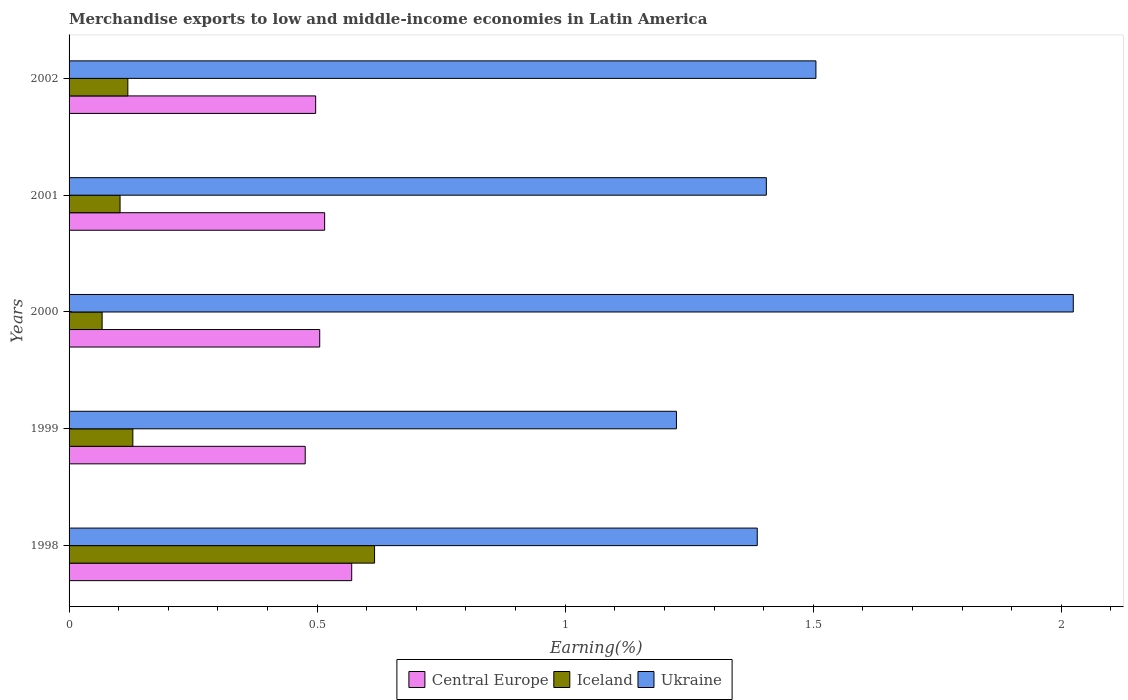How many different coloured bars are there?
Offer a very short reply. 3. How many groups of bars are there?
Make the answer very short. 5. Are the number of bars per tick equal to the number of legend labels?
Your answer should be compact. Yes. How many bars are there on the 5th tick from the top?
Offer a terse response. 3. How many bars are there on the 3rd tick from the bottom?
Offer a terse response. 3. What is the label of the 4th group of bars from the top?
Ensure brevity in your answer.  1999. In how many cases, is the number of bars for a given year not equal to the number of legend labels?
Provide a short and direct response. 0. What is the percentage of amount earned from merchandise exports in Central Europe in 2002?
Provide a short and direct response. 0.5. Across all years, what is the maximum percentage of amount earned from merchandise exports in Iceland?
Keep it short and to the point. 0.62. Across all years, what is the minimum percentage of amount earned from merchandise exports in Ukraine?
Give a very brief answer. 1.22. What is the total percentage of amount earned from merchandise exports in Central Europe in the graph?
Keep it short and to the point. 2.56. What is the difference between the percentage of amount earned from merchandise exports in Central Europe in 1998 and that in 1999?
Your answer should be very brief. 0.09. What is the difference between the percentage of amount earned from merchandise exports in Iceland in 2000 and the percentage of amount earned from merchandise exports in Ukraine in 1998?
Your answer should be compact. -1.32. What is the average percentage of amount earned from merchandise exports in Ukraine per year?
Give a very brief answer. 1.51. In the year 1998, what is the difference between the percentage of amount earned from merchandise exports in Iceland and percentage of amount earned from merchandise exports in Central Europe?
Ensure brevity in your answer.  0.05. What is the ratio of the percentage of amount earned from merchandise exports in Ukraine in 1999 to that in 2000?
Offer a terse response. 0.6. Is the percentage of amount earned from merchandise exports in Ukraine in 1998 less than that in 2002?
Your response must be concise. Yes. Is the difference between the percentage of amount earned from merchandise exports in Iceland in 1999 and 2000 greater than the difference between the percentage of amount earned from merchandise exports in Central Europe in 1999 and 2000?
Make the answer very short. Yes. What is the difference between the highest and the second highest percentage of amount earned from merchandise exports in Iceland?
Give a very brief answer. 0.49. What is the difference between the highest and the lowest percentage of amount earned from merchandise exports in Iceland?
Provide a succinct answer. 0.55. Is the sum of the percentage of amount earned from merchandise exports in Iceland in 2000 and 2002 greater than the maximum percentage of amount earned from merchandise exports in Ukraine across all years?
Offer a terse response. No. What does the 3rd bar from the top in 2000 represents?
Make the answer very short. Central Europe. What does the 3rd bar from the bottom in 2000 represents?
Make the answer very short. Ukraine. Are all the bars in the graph horizontal?
Give a very brief answer. Yes. How many years are there in the graph?
Your answer should be compact. 5. Does the graph contain grids?
Provide a succinct answer. No. Where does the legend appear in the graph?
Provide a succinct answer. Bottom center. How are the legend labels stacked?
Ensure brevity in your answer.  Horizontal. What is the title of the graph?
Provide a short and direct response. Merchandise exports to low and middle-income economies in Latin America. What is the label or title of the X-axis?
Provide a short and direct response. Earning(%). What is the Earning(%) of Central Europe in 1998?
Offer a terse response. 0.57. What is the Earning(%) of Iceland in 1998?
Provide a short and direct response. 0.62. What is the Earning(%) of Ukraine in 1998?
Make the answer very short. 1.39. What is the Earning(%) in Central Europe in 1999?
Provide a succinct answer. 0.48. What is the Earning(%) in Iceland in 1999?
Ensure brevity in your answer.  0.13. What is the Earning(%) of Ukraine in 1999?
Ensure brevity in your answer.  1.22. What is the Earning(%) in Central Europe in 2000?
Offer a terse response. 0.51. What is the Earning(%) of Iceland in 2000?
Provide a short and direct response. 0.07. What is the Earning(%) in Ukraine in 2000?
Your answer should be compact. 2.02. What is the Earning(%) of Central Europe in 2001?
Make the answer very short. 0.52. What is the Earning(%) of Iceland in 2001?
Your answer should be compact. 0.1. What is the Earning(%) in Ukraine in 2001?
Offer a very short reply. 1.41. What is the Earning(%) of Central Europe in 2002?
Make the answer very short. 0.5. What is the Earning(%) of Iceland in 2002?
Make the answer very short. 0.12. What is the Earning(%) in Ukraine in 2002?
Your response must be concise. 1.51. Across all years, what is the maximum Earning(%) in Central Europe?
Ensure brevity in your answer.  0.57. Across all years, what is the maximum Earning(%) in Iceland?
Your response must be concise. 0.62. Across all years, what is the maximum Earning(%) of Ukraine?
Provide a short and direct response. 2.02. Across all years, what is the minimum Earning(%) of Central Europe?
Offer a terse response. 0.48. Across all years, what is the minimum Earning(%) in Iceland?
Provide a short and direct response. 0.07. Across all years, what is the minimum Earning(%) of Ukraine?
Your answer should be very brief. 1.22. What is the total Earning(%) in Central Europe in the graph?
Your response must be concise. 2.56. What is the total Earning(%) in Iceland in the graph?
Keep it short and to the point. 1.03. What is the total Earning(%) of Ukraine in the graph?
Your answer should be very brief. 7.55. What is the difference between the Earning(%) in Central Europe in 1998 and that in 1999?
Offer a terse response. 0.09. What is the difference between the Earning(%) in Iceland in 1998 and that in 1999?
Provide a short and direct response. 0.49. What is the difference between the Earning(%) of Ukraine in 1998 and that in 1999?
Make the answer very short. 0.16. What is the difference between the Earning(%) in Central Europe in 1998 and that in 2000?
Your response must be concise. 0.06. What is the difference between the Earning(%) of Iceland in 1998 and that in 2000?
Ensure brevity in your answer.  0.55. What is the difference between the Earning(%) in Ukraine in 1998 and that in 2000?
Ensure brevity in your answer.  -0.64. What is the difference between the Earning(%) in Central Europe in 1998 and that in 2001?
Ensure brevity in your answer.  0.05. What is the difference between the Earning(%) in Iceland in 1998 and that in 2001?
Your answer should be compact. 0.51. What is the difference between the Earning(%) in Ukraine in 1998 and that in 2001?
Give a very brief answer. -0.02. What is the difference between the Earning(%) of Central Europe in 1998 and that in 2002?
Your response must be concise. 0.07. What is the difference between the Earning(%) of Iceland in 1998 and that in 2002?
Offer a very short reply. 0.5. What is the difference between the Earning(%) of Ukraine in 1998 and that in 2002?
Provide a succinct answer. -0.12. What is the difference between the Earning(%) in Central Europe in 1999 and that in 2000?
Keep it short and to the point. -0.03. What is the difference between the Earning(%) in Iceland in 1999 and that in 2000?
Your response must be concise. 0.06. What is the difference between the Earning(%) in Ukraine in 1999 and that in 2000?
Offer a very short reply. -0.8. What is the difference between the Earning(%) in Central Europe in 1999 and that in 2001?
Your answer should be very brief. -0.04. What is the difference between the Earning(%) in Iceland in 1999 and that in 2001?
Make the answer very short. 0.03. What is the difference between the Earning(%) in Ukraine in 1999 and that in 2001?
Offer a very short reply. -0.18. What is the difference between the Earning(%) of Central Europe in 1999 and that in 2002?
Give a very brief answer. -0.02. What is the difference between the Earning(%) in Iceland in 1999 and that in 2002?
Make the answer very short. 0.01. What is the difference between the Earning(%) in Ukraine in 1999 and that in 2002?
Your response must be concise. -0.28. What is the difference between the Earning(%) in Central Europe in 2000 and that in 2001?
Provide a short and direct response. -0.01. What is the difference between the Earning(%) in Iceland in 2000 and that in 2001?
Give a very brief answer. -0.04. What is the difference between the Earning(%) of Ukraine in 2000 and that in 2001?
Give a very brief answer. 0.62. What is the difference between the Earning(%) in Central Europe in 2000 and that in 2002?
Provide a short and direct response. 0.01. What is the difference between the Earning(%) of Iceland in 2000 and that in 2002?
Offer a very short reply. -0.05. What is the difference between the Earning(%) of Ukraine in 2000 and that in 2002?
Offer a terse response. 0.52. What is the difference between the Earning(%) in Central Europe in 2001 and that in 2002?
Your response must be concise. 0.02. What is the difference between the Earning(%) in Iceland in 2001 and that in 2002?
Give a very brief answer. -0.02. What is the difference between the Earning(%) of Central Europe in 1998 and the Earning(%) of Iceland in 1999?
Provide a succinct answer. 0.44. What is the difference between the Earning(%) of Central Europe in 1998 and the Earning(%) of Ukraine in 1999?
Your answer should be very brief. -0.65. What is the difference between the Earning(%) of Iceland in 1998 and the Earning(%) of Ukraine in 1999?
Your response must be concise. -0.61. What is the difference between the Earning(%) of Central Europe in 1998 and the Earning(%) of Iceland in 2000?
Provide a short and direct response. 0.5. What is the difference between the Earning(%) in Central Europe in 1998 and the Earning(%) in Ukraine in 2000?
Offer a very short reply. -1.45. What is the difference between the Earning(%) of Iceland in 1998 and the Earning(%) of Ukraine in 2000?
Keep it short and to the point. -1.41. What is the difference between the Earning(%) of Central Europe in 1998 and the Earning(%) of Iceland in 2001?
Provide a short and direct response. 0.47. What is the difference between the Earning(%) of Central Europe in 1998 and the Earning(%) of Ukraine in 2001?
Provide a short and direct response. -0.84. What is the difference between the Earning(%) of Iceland in 1998 and the Earning(%) of Ukraine in 2001?
Make the answer very short. -0.79. What is the difference between the Earning(%) in Central Europe in 1998 and the Earning(%) in Iceland in 2002?
Offer a terse response. 0.45. What is the difference between the Earning(%) in Central Europe in 1998 and the Earning(%) in Ukraine in 2002?
Keep it short and to the point. -0.94. What is the difference between the Earning(%) in Iceland in 1998 and the Earning(%) in Ukraine in 2002?
Ensure brevity in your answer.  -0.89. What is the difference between the Earning(%) in Central Europe in 1999 and the Earning(%) in Iceland in 2000?
Provide a short and direct response. 0.41. What is the difference between the Earning(%) in Central Europe in 1999 and the Earning(%) in Ukraine in 2000?
Your response must be concise. -1.55. What is the difference between the Earning(%) in Iceland in 1999 and the Earning(%) in Ukraine in 2000?
Your answer should be compact. -1.9. What is the difference between the Earning(%) in Central Europe in 1999 and the Earning(%) in Iceland in 2001?
Make the answer very short. 0.37. What is the difference between the Earning(%) of Central Europe in 1999 and the Earning(%) of Ukraine in 2001?
Offer a very short reply. -0.93. What is the difference between the Earning(%) of Iceland in 1999 and the Earning(%) of Ukraine in 2001?
Give a very brief answer. -1.28. What is the difference between the Earning(%) of Central Europe in 1999 and the Earning(%) of Iceland in 2002?
Offer a very short reply. 0.36. What is the difference between the Earning(%) of Central Europe in 1999 and the Earning(%) of Ukraine in 2002?
Your answer should be compact. -1.03. What is the difference between the Earning(%) in Iceland in 1999 and the Earning(%) in Ukraine in 2002?
Provide a short and direct response. -1.38. What is the difference between the Earning(%) of Central Europe in 2000 and the Earning(%) of Iceland in 2001?
Keep it short and to the point. 0.4. What is the difference between the Earning(%) in Central Europe in 2000 and the Earning(%) in Ukraine in 2001?
Provide a succinct answer. -0.9. What is the difference between the Earning(%) in Iceland in 2000 and the Earning(%) in Ukraine in 2001?
Offer a very short reply. -1.34. What is the difference between the Earning(%) in Central Europe in 2000 and the Earning(%) in Iceland in 2002?
Provide a succinct answer. 0.39. What is the difference between the Earning(%) in Central Europe in 2000 and the Earning(%) in Ukraine in 2002?
Give a very brief answer. -1. What is the difference between the Earning(%) of Iceland in 2000 and the Earning(%) of Ukraine in 2002?
Your answer should be very brief. -1.44. What is the difference between the Earning(%) in Central Europe in 2001 and the Earning(%) in Iceland in 2002?
Offer a very short reply. 0.4. What is the difference between the Earning(%) in Central Europe in 2001 and the Earning(%) in Ukraine in 2002?
Give a very brief answer. -0.99. What is the difference between the Earning(%) of Iceland in 2001 and the Earning(%) of Ukraine in 2002?
Give a very brief answer. -1.4. What is the average Earning(%) in Central Europe per year?
Give a very brief answer. 0.51. What is the average Earning(%) of Iceland per year?
Offer a very short reply. 0.21. What is the average Earning(%) in Ukraine per year?
Provide a short and direct response. 1.51. In the year 1998, what is the difference between the Earning(%) in Central Europe and Earning(%) in Iceland?
Your response must be concise. -0.05. In the year 1998, what is the difference between the Earning(%) of Central Europe and Earning(%) of Ukraine?
Your response must be concise. -0.82. In the year 1998, what is the difference between the Earning(%) in Iceland and Earning(%) in Ukraine?
Your answer should be very brief. -0.77. In the year 1999, what is the difference between the Earning(%) in Central Europe and Earning(%) in Iceland?
Your answer should be very brief. 0.35. In the year 1999, what is the difference between the Earning(%) in Central Europe and Earning(%) in Ukraine?
Keep it short and to the point. -0.75. In the year 1999, what is the difference between the Earning(%) in Iceland and Earning(%) in Ukraine?
Provide a succinct answer. -1.1. In the year 2000, what is the difference between the Earning(%) of Central Europe and Earning(%) of Iceland?
Provide a short and direct response. 0.44. In the year 2000, what is the difference between the Earning(%) of Central Europe and Earning(%) of Ukraine?
Offer a very short reply. -1.52. In the year 2000, what is the difference between the Earning(%) of Iceland and Earning(%) of Ukraine?
Your answer should be compact. -1.96. In the year 2001, what is the difference between the Earning(%) in Central Europe and Earning(%) in Iceland?
Give a very brief answer. 0.41. In the year 2001, what is the difference between the Earning(%) in Central Europe and Earning(%) in Ukraine?
Your answer should be very brief. -0.89. In the year 2001, what is the difference between the Earning(%) of Iceland and Earning(%) of Ukraine?
Keep it short and to the point. -1.3. In the year 2002, what is the difference between the Earning(%) in Central Europe and Earning(%) in Iceland?
Keep it short and to the point. 0.38. In the year 2002, what is the difference between the Earning(%) of Central Europe and Earning(%) of Ukraine?
Provide a short and direct response. -1.01. In the year 2002, what is the difference between the Earning(%) in Iceland and Earning(%) in Ukraine?
Your answer should be very brief. -1.39. What is the ratio of the Earning(%) in Central Europe in 1998 to that in 1999?
Give a very brief answer. 1.2. What is the ratio of the Earning(%) in Iceland in 1998 to that in 1999?
Give a very brief answer. 4.79. What is the ratio of the Earning(%) of Ukraine in 1998 to that in 1999?
Keep it short and to the point. 1.13. What is the ratio of the Earning(%) in Central Europe in 1998 to that in 2000?
Your answer should be very brief. 1.13. What is the ratio of the Earning(%) in Iceland in 1998 to that in 2000?
Offer a very short reply. 9.24. What is the ratio of the Earning(%) of Ukraine in 1998 to that in 2000?
Make the answer very short. 0.69. What is the ratio of the Earning(%) in Central Europe in 1998 to that in 2001?
Ensure brevity in your answer.  1.11. What is the ratio of the Earning(%) of Iceland in 1998 to that in 2001?
Ensure brevity in your answer.  5.99. What is the ratio of the Earning(%) of Ukraine in 1998 to that in 2001?
Give a very brief answer. 0.99. What is the ratio of the Earning(%) in Central Europe in 1998 to that in 2002?
Your response must be concise. 1.15. What is the ratio of the Earning(%) of Iceland in 1998 to that in 2002?
Your answer should be very brief. 5.2. What is the ratio of the Earning(%) in Ukraine in 1998 to that in 2002?
Keep it short and to the point. 0.92. What is the ratio of the Earning(%) of Central Europe in 1999 to that in 2000?
Give a very brief answer. 0.94. What is the ratio of the Earning(%) of Iceland in 1999 to that in 2000?
Offer a terse response. 1.93. What is the ratio of the Earning(%) of Ukraine in 1999 to that in 2000?
Provide a succinct answer. 0.6. What is the ratio of the Earning(%) of Central Europe in 1999 to that in 2001?
Make the answer very short. 0.92. What is the ratio of the Earning(%) in Iceland in 1999 to that in 2001?
Your answer should be very brief. 1.25. What is the ratio of the Earning(%) of Ukraine in 1999 to that in 2001?
Your response must be concise. 0.87. What is the ratio of the Earning(%) of Central Europe in 1999 to that in 2002?
Your response must be concise. 0.96. What is the ratio of the Earning(%) in Iceland in 1999 to that in 2002?
Make the answer very short. 1.09. What is the ratio of the Earning(%) in Ukraine in 1999 to that in 2002?
Ensure brevity in your answer.  0.81. What is the ratio of the Earning(%) in Central Europe in 2000 to that in 2001?
Keep it short and to the point. 0.98. What is the ratio of the Earning(%) of Iceland in 2000 to that in 2001?
Provide a succinct answer. 0.65. What is the ratio of the Earning(%) in Ukraine in 2000 to that in 2001?
Ensure brevity in your answer.  1.44. What is the ratio of the Earning(%) in Central Europe in 2000 to that in 2002?
Offer a very short reply. 1.02. What is the ratio of the Earning(%) of Iceland in 2000 to that in 2002?
Your response must be concise. 0.56. What is the ratio of the Earning(%) of Ukraine in 2000 to that in 2002?
Offer a very short reply. 1.34. What is the ratio of the Earning(%) of Central Europe in 2001 to that in 2002?
Ensure brevity in your answer.  1.04. What is the ratio of the Earning(%) of Iceland in 2001 to that in 2002?
Offer a terse response. 0.87. What is the ratio of the Earning(%) of Ukraine in 2001 to that in 2002?
Provide a succinct answer. 0.93. What is the difference between the highest and the second highest Earning(%) of Central Europe?
Offer a very short reply. 0.05. What is the difference between the highest and the second highest Earning(%) in Iceland?
Keep it short and to the point. 0.49. What is the difference between the highest and the second highest Earning(%) in Ukraine?
Offer a very short reply. 0.52. What is the difference between the highest and the lowest Earning(%) of Central Europe?
Your answer should be compact. 0.09. What is the difference between the highest and the lowest Earning(%) of Iceland?
Offer a very short reply. 0.55. What is the difference between the highest and the lowest Earning(%) of Ukraine?
Make the answer very short. 0.8. 